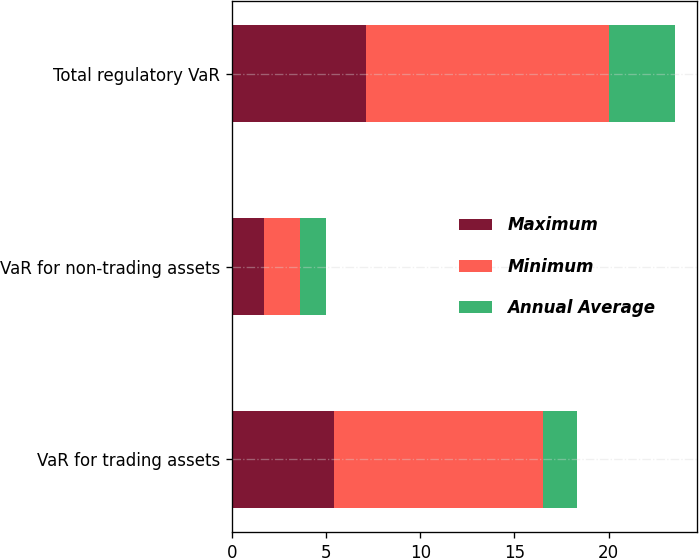Convert chart to OTSL. <chart><loc_0><loc_0><loc_500><loc_500><stacked_bar_chart><ecel><fcel>VaR for trading assets<fcel>VaR for non-trading assets<fcel>Total regulatory VaR<nl><fcel>Maximum<fcel>5.4<fcel>1.7<fcel>7.1<nl><fcel>Minimum<fcel>11.1<fcel>1.9<fcel>12.9<nl><fcel>Annual Average<fcel>1.8<fcel>1.4<fcel>3.5<nl></chart> 